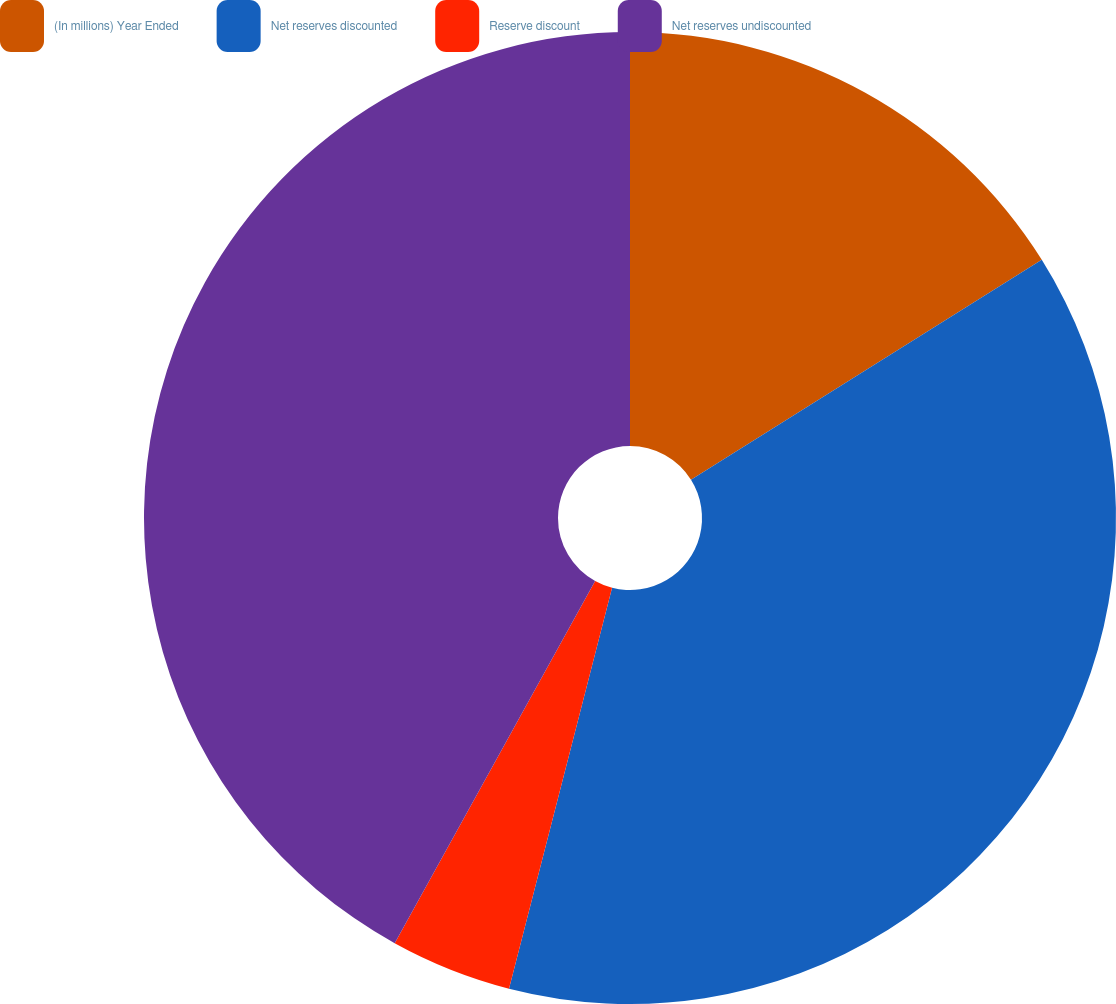<chart> <loc_0><loc_0><loc_500><loc_500><pie_chart><fcel>(In millions) Year Ended<fcel>Net reserves discounted<fcel>Reserve discount<fcel>Net reserves undiscounted<nl><fcel>16.09%<fcel>37.92%<fcel>4.04%<fcel>41.96%<nl></chart> 